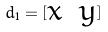<formula> <loc_0><loc_0><loc_500><loc_500>d _ { 1 } = [ \begin{matrix} x & y \\ \end{matrix} ]</formula> 